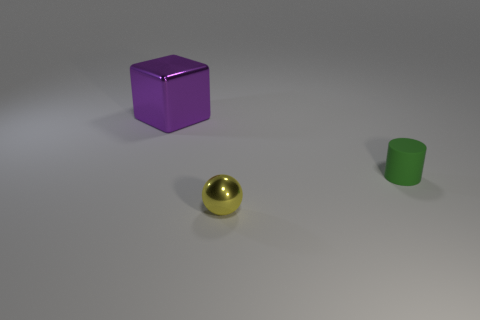Are there any matte objects that have the same shape as the yellow metallic object?
Provide a succinct answer. No. What is the material of the large purple thing?
Your answer should be very brief. Metal. How big is the thing that is on the left side of the small green cylinder and behind the yellow metallic ball?
Your answer should be very brief. Large. How many rubber things are there?
Provide a succinct answer. 1. Are there fewer large yellow metal blocks than small green rubber cylinders?
Your response must be concise. Yes. There is another thing that is the same size as the green object; what is it made of?
Your answer should be very brief. Metal. How many objects are either yellow shiny objects or big cubes?
Give a very brief answer. 2. What number of objects are both to the left of the small rubber cylinder and in front of the large metallic cube?
Make the answer very short. 1. Is the number of small things that are in front of the tiny yellow metallic thing less than the number of cubes?
Offer a very short reply. Yes. What shape is the object that is the same size as the yellow ball?
Offer a very short reply. Cylinder. 